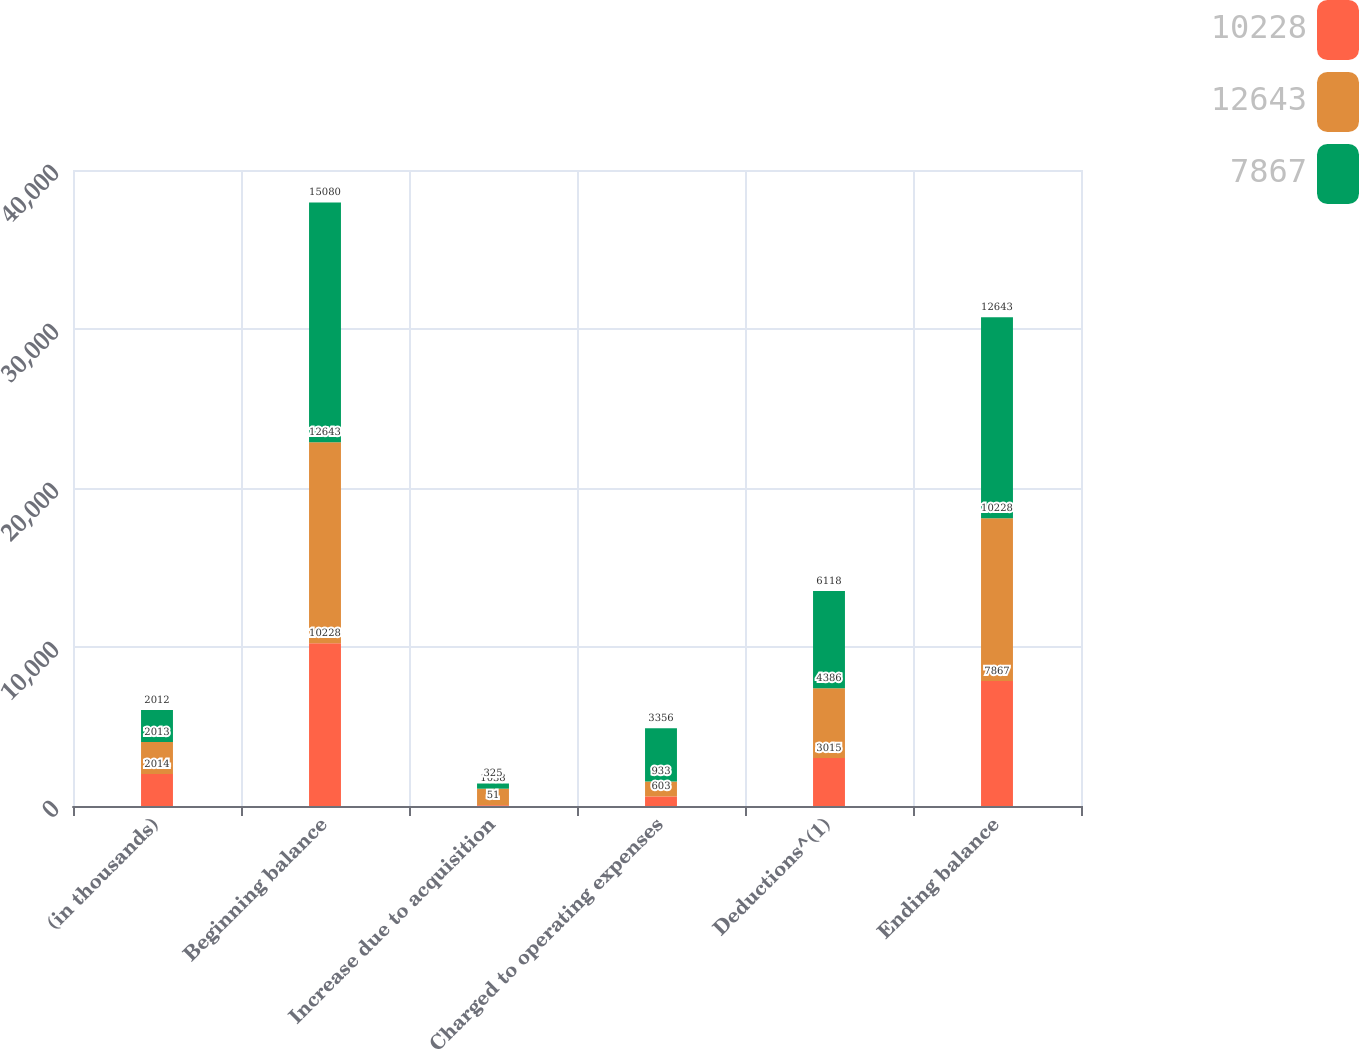Convert chart to OTSL. <chart><loc_0><loc_0><loc_500><loc_500><stacked_bar_chart><ecel><fcel>(in thousands)<fcel>Beginning balance<fcel>Increase due to acquisition<fcel>Charged to operating expenses<fcel>Deductions^(1)<fcel>Ending balance<nl><fcel>10228<fcel>2014<fcel>10228<fcel>51<fcel>603<fcel>3015<fcel>7867<nl><fcel>12643<fcel>2013<fcel>12643<fcel>1038<fcel>933<fcel>4386<fcel>10228<nl><fcel>7867<fcel>2012<fcel>15080<fcel>325<fcel>3356<fcel>6118<fcel>12643<nl></chart> 